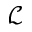Convert formula to latex. <formula><loc_0><loc_0><loc_500><loc_500>\mathcal { L }</formula> 